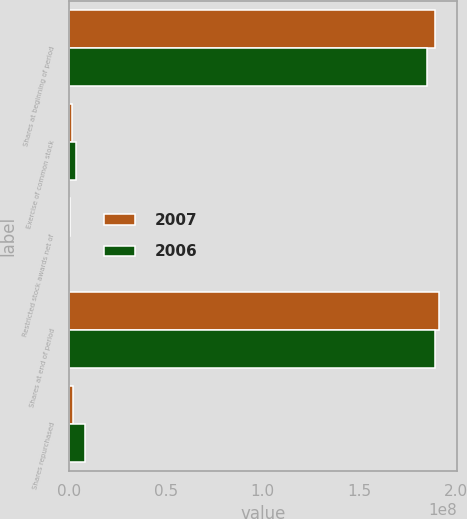<chart> <loc_0><loc_0><loc_500><loc_500><stacked_bar_chart><ecel><fcel>Shares at beginning of period<fcel>Exercise of common stock<fcel>Restricted stock awards net of<fcel>Shares at end of period<fcel>Shares repurchased<nl><fcel>2007<fcel>1.88808e+08<fcel>1.47904e+06<fcel>527182<fcel>1.90814e+08<fcel>2.00648e+06<nl><fcel>2006<fcel>1.84894e+08<fcel>3.84852e+06<fcel>66056<fcel>1.88808e+08<fcel>8.3734e+06<nl></chart> 